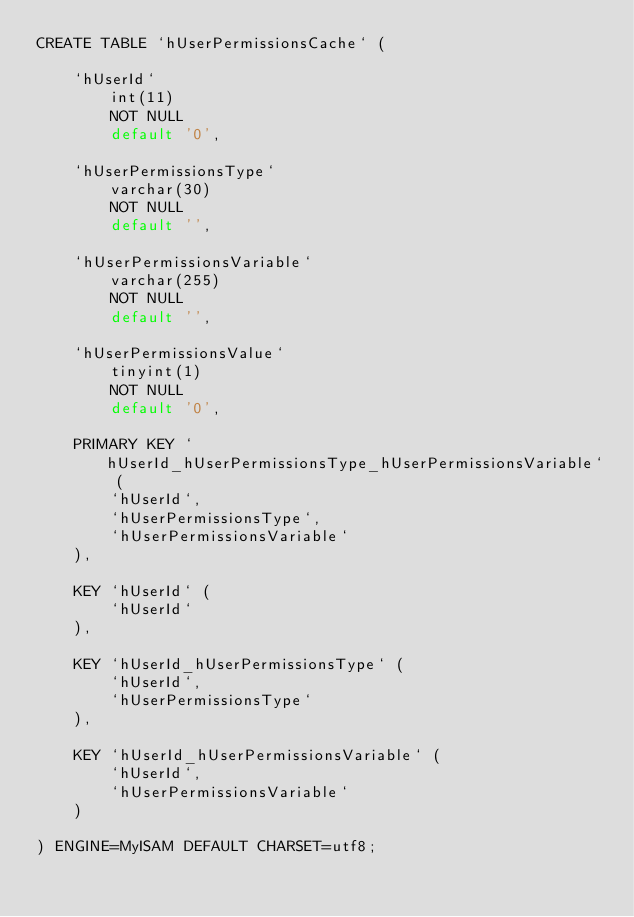<code> <loc_0><loc_0><loc_500><loc_500><_SQL_>CREATE TABLE `hUserPermissionsCache` (

    `hUserId`
        int(11)
        NOT NULL
        default '0',

    `hUserPermissionsType`
        varchar(30)
        NOT NULL
        default '',

    `hUserPermissionsVariable`
        varchar(255)
        NOT NULL
        default '',

    `hUserPermissionsValue`
        tinyint(1)
        NOT NULL
        default '0',

    PRIMARY KEY `hUserId_hUserPermissionsType_hUserPermissionsVariable` (
        `hUserId`,
        `hUserPermissionsType`,
        `hUserPermissionsVariable`
    ),

    KEY `hUserId` (
        `hUserId`
    ),

    KEY `hUserId_hUserPermissionsType` (
        `hUserId`,
        `hUserPermissionsType`
    ),

    KEY `hUserId_hUserPermissionsVariable` (
        `hUserId`,
        `hUserPermissionsVariable`
    )

) ENGINE=MyISAM DEFAULT CHARSET=utf8;</code> 